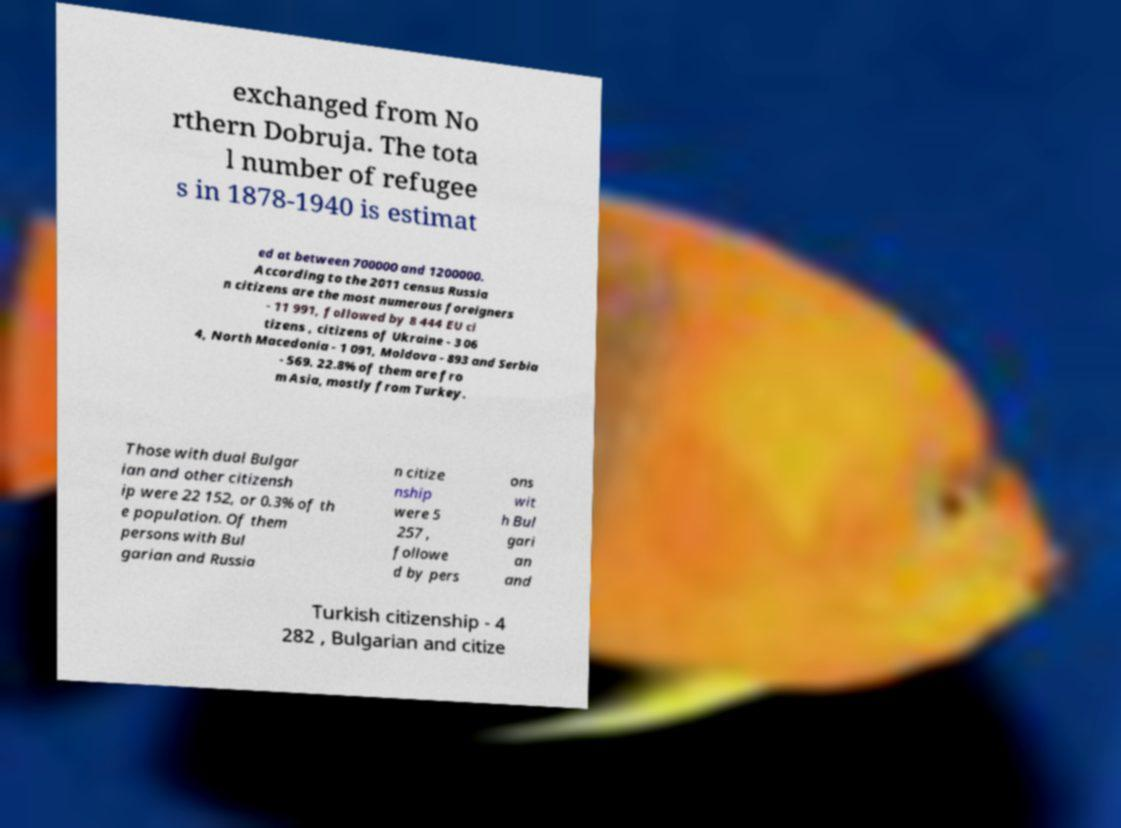Can you accurately transcribe the text from the provided image for me? exchanged from No rthern Dobruja. The tota l number of refugee s in 1878-1940 is estimat ed at between 700000 and 1200000. According to the 2011 census Russia n citizens are the most numerous foreigners - 11 991, followed by 8 444 EU ci tizens , citizens of Ukraine - 3 06 4, North Macedonia - 1 091, Moldova - 893 and Serbia - 569. 22.8% of them are fro m Asia, mostly from Turkey. Those with dual Bulgar ian and other citizensh ip were 22 152, or 0.3% of th e population. Of them persons with Bul garian and Russia n citize nship were 5 257 , followe d by pers ons wit h Bul gari an and Turkish citizenship - 4 282 , Bulgarian and citize 